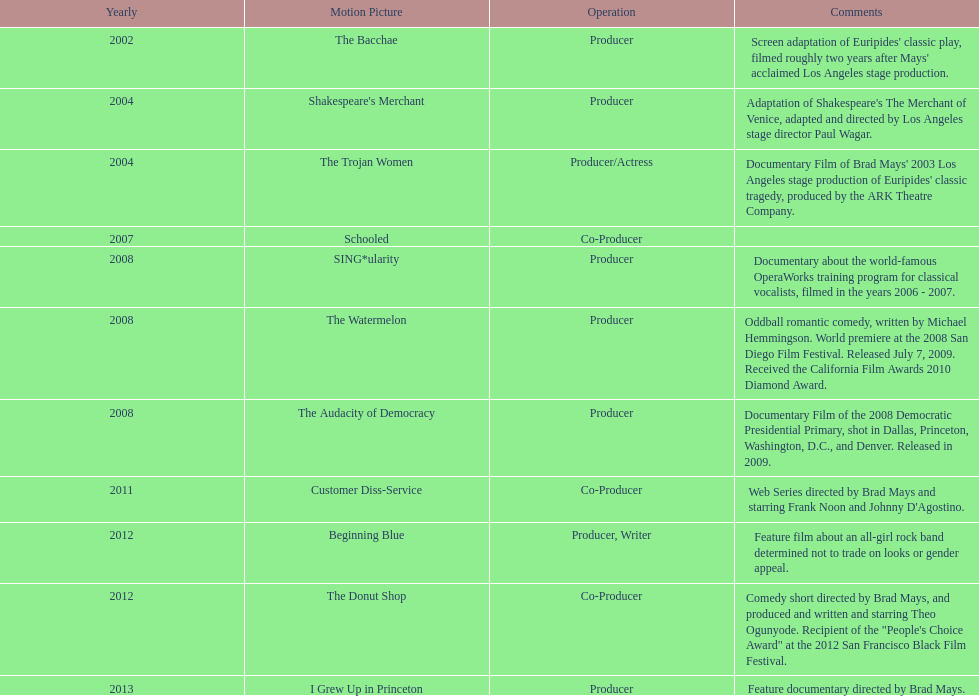In which year did ms. starfelt produce the most films? 2008. 